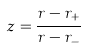Convert formula to latex. <formula><loc_0><loc_0><loc_500><loc_500>z = \frac { r - r _ { + } } { r - r _ { - } }</formula> 